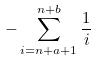<formula> <loc_0><loc_0><loc_500><loc_500>- \sum _ { i = n + a + 1 } ^ { n + b } \frac { 1 } { i }</formula> 